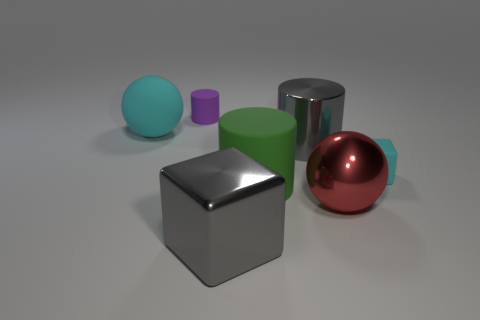Subtract all metal cylinders. How many cylinders are left? 2 Subtract all cyan balls. How many balls are left? 1 Add 2 large purple cubes. How many objects exist? 9 Subtract 0 gray balls. How many objects are left? 7 Subtract all cylinders. How many objects are left? 4 Subtract 1 cylinders. How many cylinders are left? 2 Subtract all green spheres. Subtract all cyan blocks. How many spheres are left? 2 Subtract all brown spheres. How many cyan cubes are left? 1 Subtract all small cyan spheres. Subtract all red spheres. How many objects are left? 6 Add 2 large balls. How many large balls are left? 4 